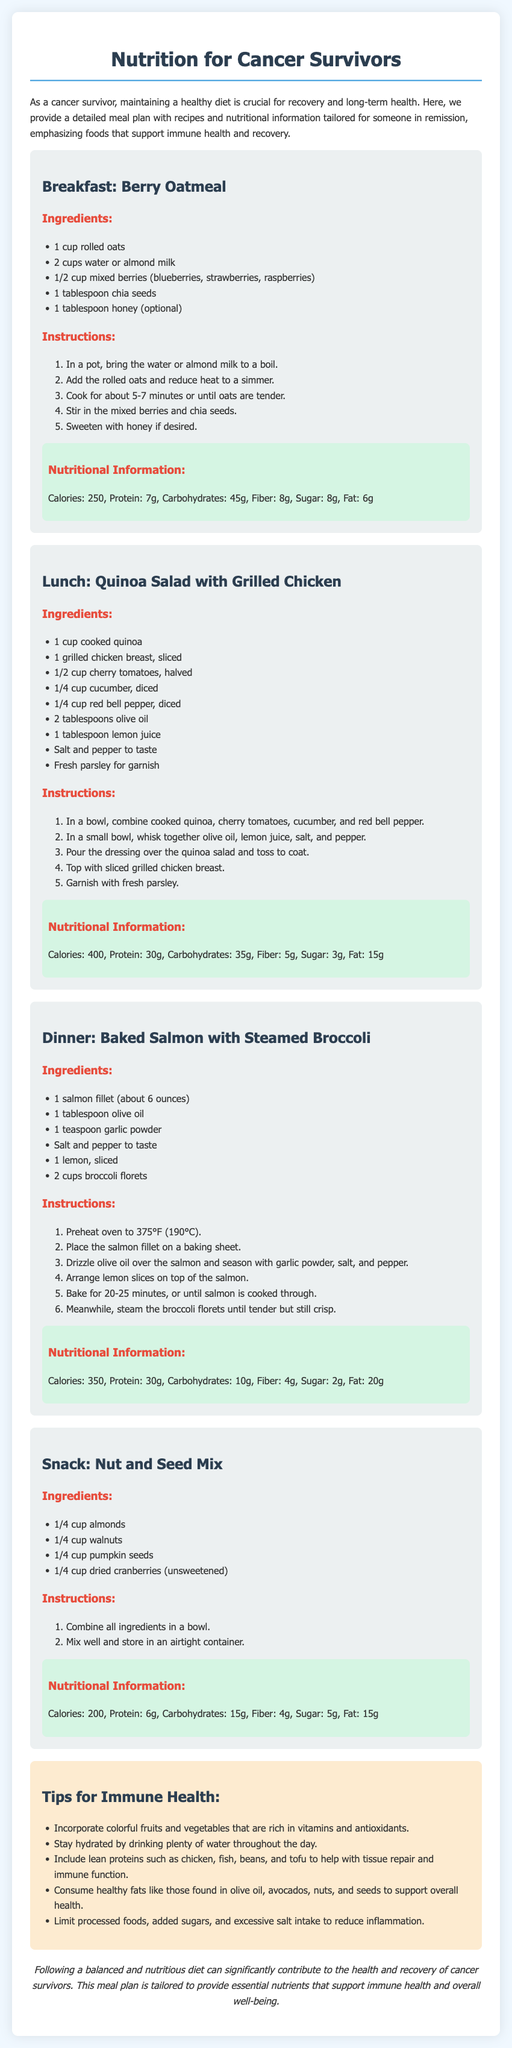What is the main focus of the document? The document is centered around nutrition specifically tailored for cancer survivors in remission.
Answer: Nutrition for cancer survivors How many ingredients are in the Baked Salmon with Steamed Broccoli recipe? The recipe lists a total of six ingredients required for preparation.
Answer: 6 What is the protein content of the Quinoa Salad with Grilled Chicken? The nutritional information states that the dish contains 30 grams of protein.
Answer: 30g What is one tip provided for immune health? The document lists several tips, one of which emphasizes the importance of colorful fruits and vegetables rich in vitamins and antioxidants.
Answer: Incorporate colorful fruits and vegetables What is the total calorie count for the snack? The nutritional information shows the Nut and Seed Mix has a total calorie count of 200.
Answer: 200 What is the cooking time for the Berry Oatmeal? The recipe mentions a cooking duration of about 5-7 minutes.
Answer: 5-7 minutes How many meals are included in the meal plan? The document presents four meals along with a snack option for cancer survivors.
Answer: 4 meals + 1 snack What type of meals are emphasized in the meal plan? The meal plan is designed to support immune health and recovery for individuals in remission.
Answer: Immune health and recovery meals 